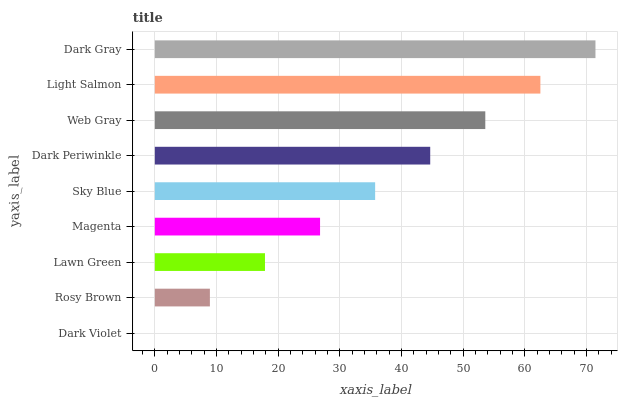Is Dark Violet the minimum?
Answer yes or no. Yes. Is Dark Gray the maximum?
Answer yes or no. Yes. Is Rosy Brown the minimum?
Answer yes or no. No. Is Rosy Brown the maximum?
Answer yes or no. No. Is Rosy Brown greater than Dark Violet?
Answer yes or no. Yes. Is Dark Violet less than Rosy Brown?
Answer yes or no. Yes. Is Dark Violet greater than Rosy Brown?
Answer yes or no. No. Is Rosy Brown less than Dark Violet?
Answer yes or no. No. Is Sky Blue the high median?
Answer yes or no. Yes. Is Sky Blue the low median?
Answer yes or no. Yes. Is Dark Periwinkle the high median?
Answer yes or no. No. Is Magenta the low median?
Answer yes or no. No. 